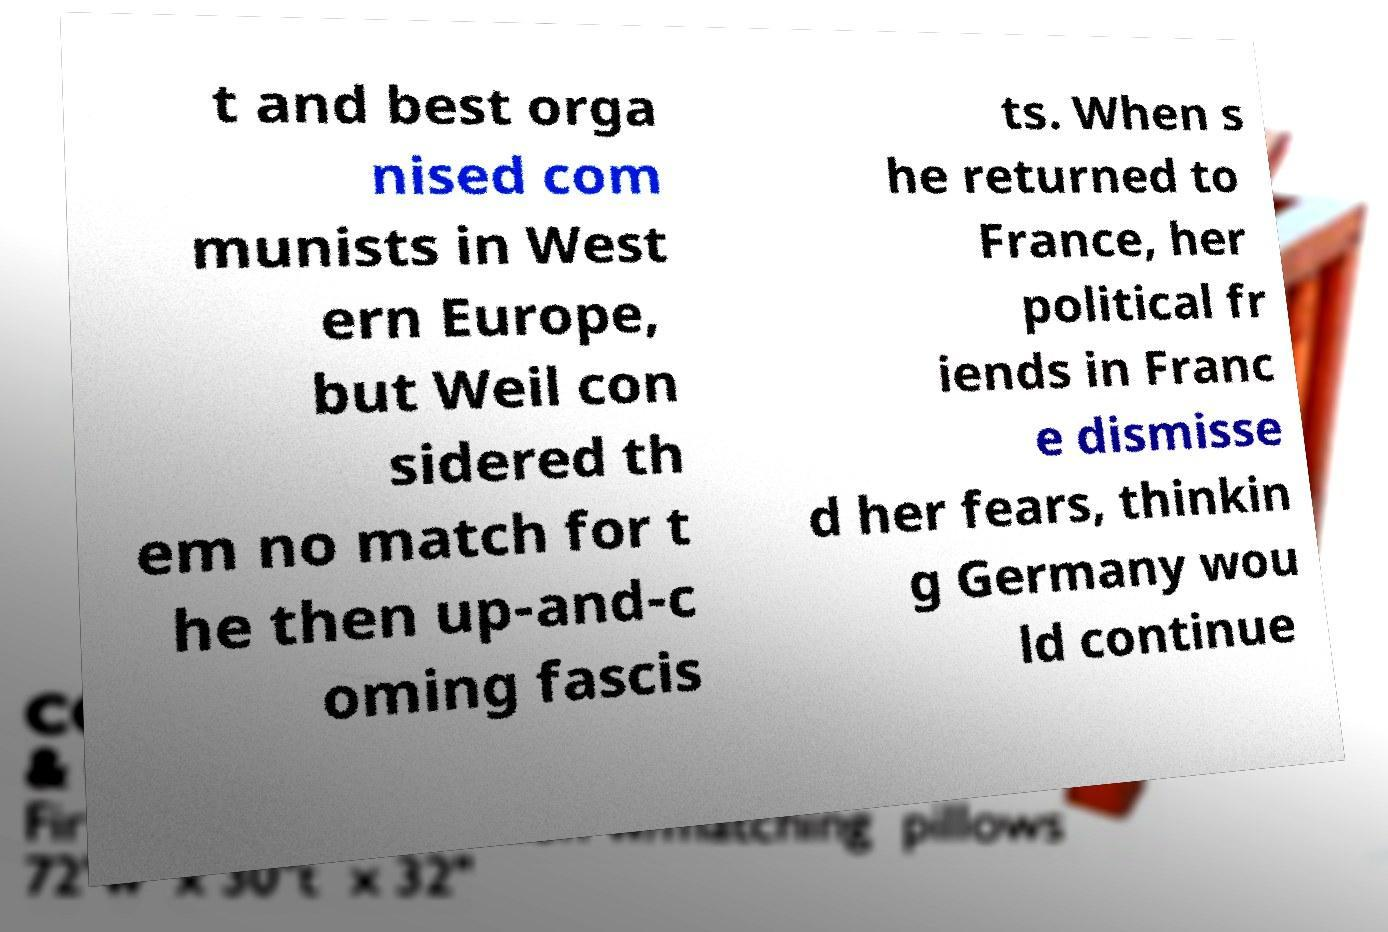What messages or text are displayed in this image? I need them in a readable, typed format. t and best orga nised com munists in West ern Europe, but Weil con sidered th em no match for t he then up-and-c oming fascis ts. When s he returned to France, her political fr iends in Franc e dismisse d her fears, thinkin g Germany wou ld continue 